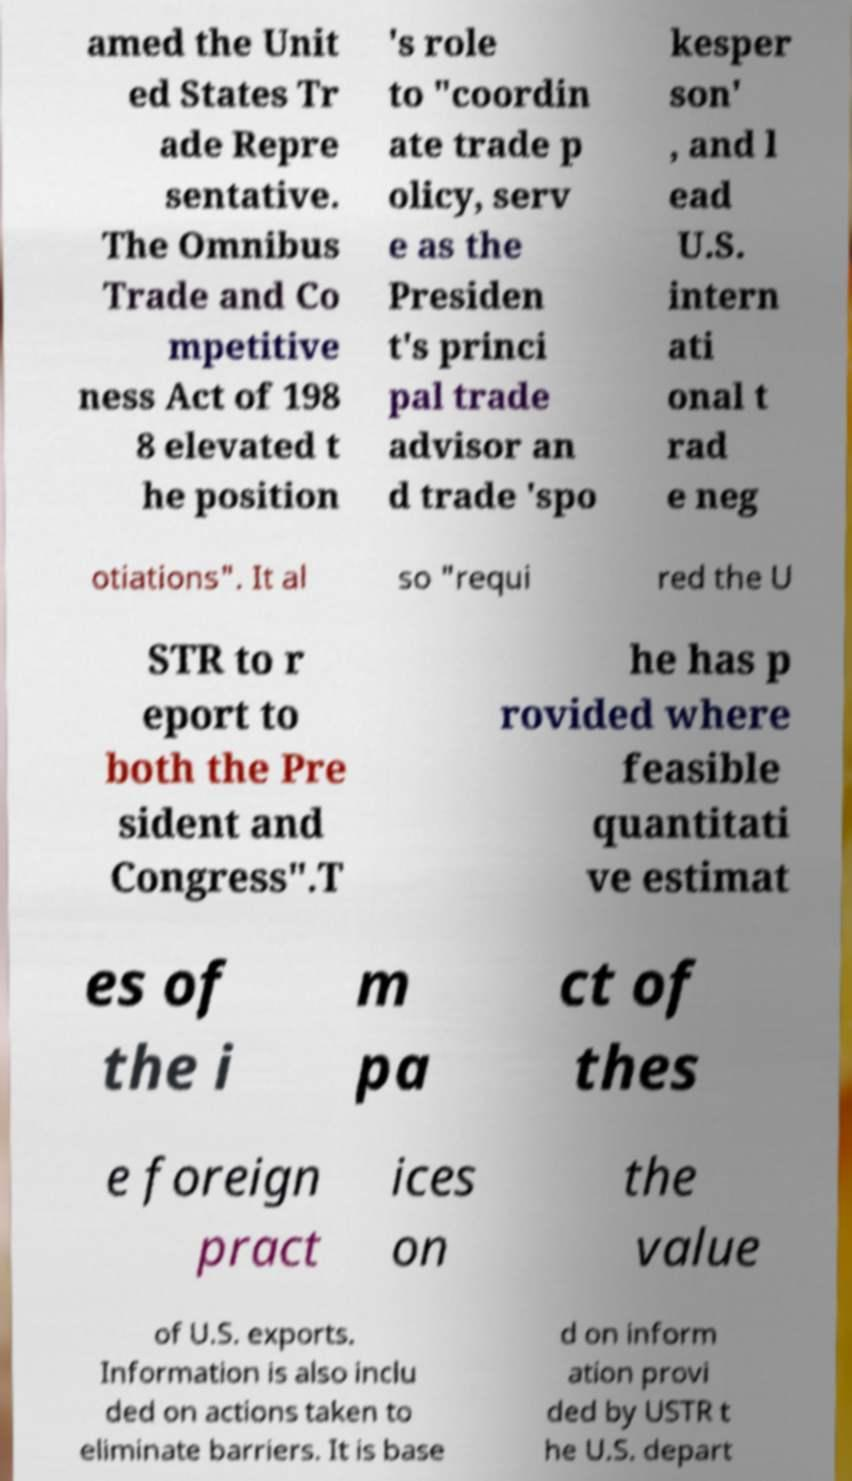Could you extract and type out the text from this image? amed the Unit ed States Tr ade Repre sentative. The Omnibus Trade and Co mpetitive ness Act of 198 8 elevated t he position 's role to "coordin ate trade p olicy, serv e as the Presiden t's princi pal trade advisor an d trade 'spo kesper son' , and l ead U.S. intern ati onal t rad e neg otiations". It al so "requi red the U STR to r eport to both the Pre sident and Congress".T he has p rovided where feasible quantitati ve estimat es of the i m pa ct of thes e foreign pract ices on the value of U.S. exports. Information is also inclu ded on actions taken to eliminate barriers. It is base d on inform ation provi ded by USTR t he U.S. depart 